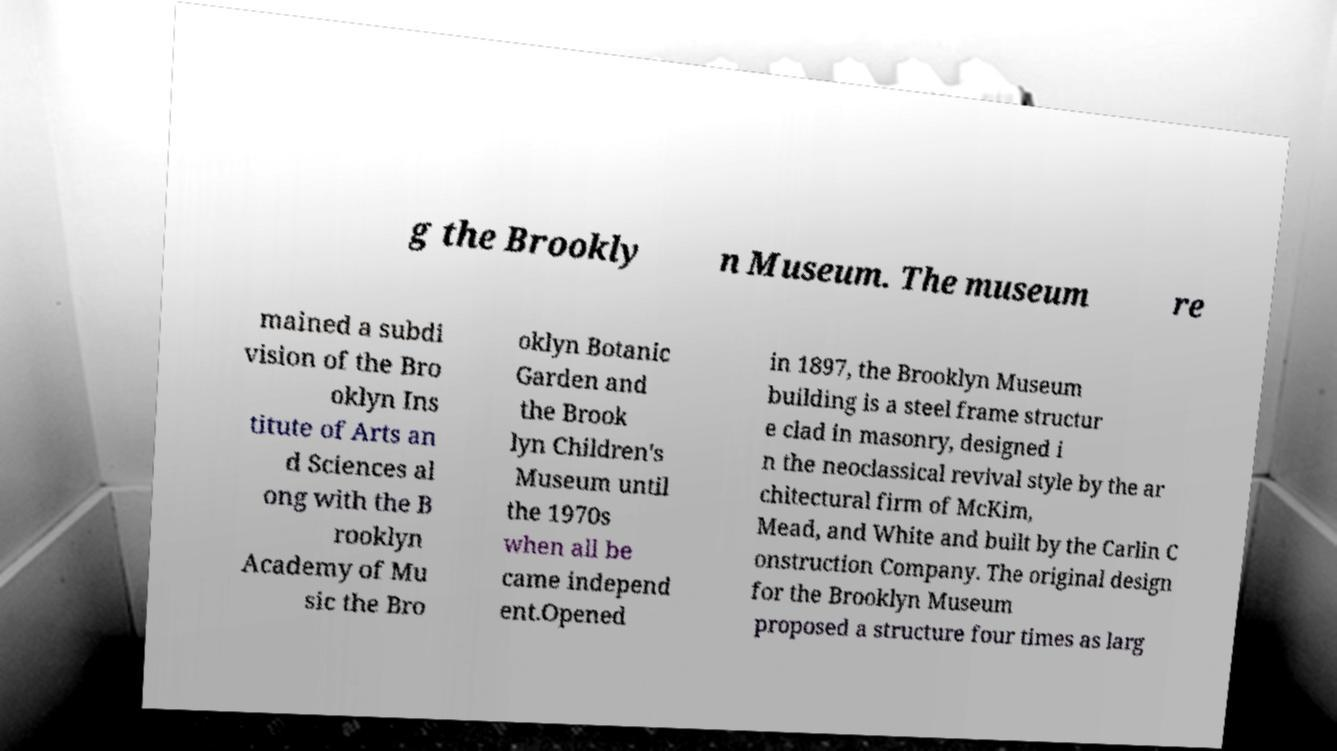I need the written content from this picture converted into text. Can you do that? g the Brookly n Museum. The museum re mained a subdi vision of the Bro oklyn Ins titute of Arts an d Sciences al ong with the B rooklyn Academy of Mu sic the Bro oklyn Botanic Garden and the Brook lyn Children's Museum until the 1970s when all be came independ ent.Opened in 1897, the Brooklyn Museum building is a steel frame structur e clad in masonry, designed i n the neoclassical revival style by the ar chitectural firm of McKim, Mead, and White and built by the Carlin C onstruction Company. The original design for the Brooklyn Museum proposed a structure four times as larg 